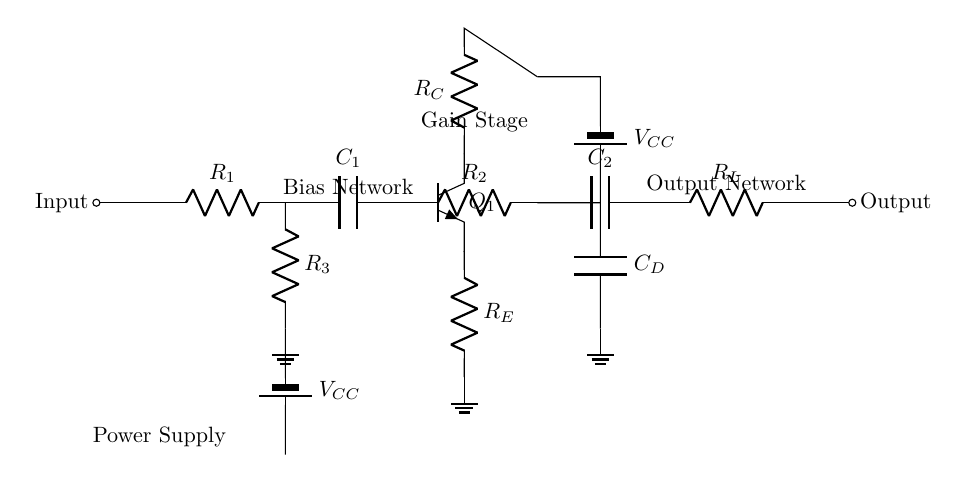What is the primary function of R1? R1 serves as a resistor in the input stage, providing initial impedance to the circuit. Its role is to limit initial current and set the input level for the following components.
Answer: Resistor What type of transistor is used in this circuit? The circuit uses an NPN transistor (Q1), evident from the labeling and the configuration of its terminals in the diagram.
Answer: NPN How many capacitors are present in the circuit? There are three capacitors shown: C1, C2, and CD. The labels and roles in the circuit indicate their use in filtering and coupling, thereby affirming their presence.
Answer: Three What component is responsible for the biasing in this circuit? R3 is responsible for the biasing in the circuit. It’s part of the voltage divider network that stabilizes the transistor’s operating point.
Answer: Resistor What is the role of C2 in this design? C2 acts as a coupling capacitor that allows AC signals to pass to the load resistor (R_L) while blocking DC components, thus ensuring only the desired audio signal is output.
Answer: Coupling What is the value of V_CC in this circuit? The value of V_CC is not given explicitly within the circuit diagram but is indicated as a power source connected to the circuit. Its numerical value typically needs to be specified based on design requirements.
Answer: Unspecified What stage is represented by the components R_E and R_C? R_E and R_C are part of the gain stage, specifically related to the output stage of the transistor, influencing the gain and stability of the amplifier.
Answer: Gain stage 